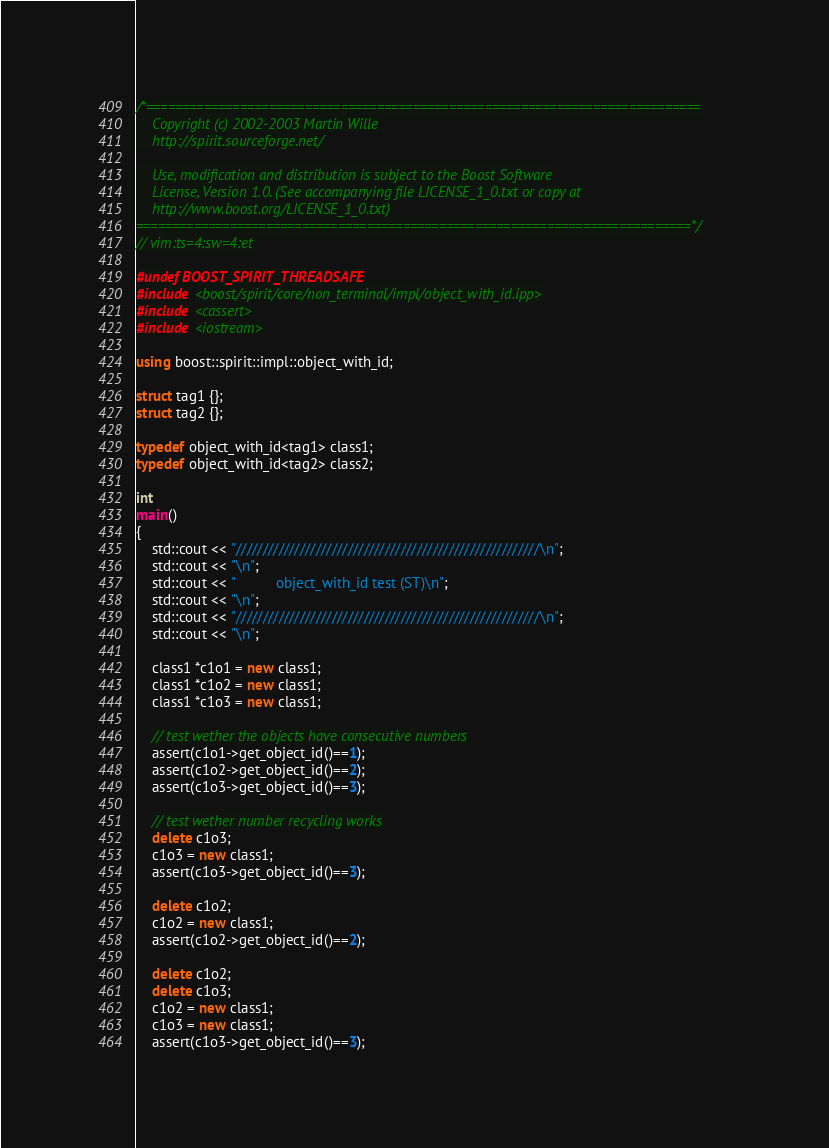<code> <loc_0><loc_0><loc_500><loc_500><_C++_>/*=============================================================================
    Copyright (c) 2002-2003 Martin Wille
    http://spirit.sourceforge.net/

    Use, modification and distribution is subject to the Boost Software
    License, Version 1.0. (See accompanying file LICENSE_1_0.txt or copy at
    http://www.boost.org/LICENSE_1_0.txt)
=============================================================================*/
// vim:ts=4:sw=4:et

#undef BOOST_SPIRIT_THREADSAFE
#include <boost/spirit/core/non_terminal/impl/object_with_id.ipp>
#include <cassert>
#include <iostream>

using boost::spirit::impl::object_with_id;

struct tag1 {};
struct tag2 {};

typedef object_with_id<tag1> class1;
typedef object_with_id<tag2> class2;

int
main()
{
    std::cout << "/////////////////////////////////////////////////////////\n";
    std::cout << "\n";
    std::cout << "          object_with_id test (ST)\n";
    std::cout << "\n";
    std::cout << "/////////////////////////////////////////////////////////\n";
    std::cout << "\n";

    class1 *c1o1 = new class1;
    class1 *c1o2 = new class1;
    class1 *c1o3 = new class1;

    // test wether the objects have consecutive numbers
    assert(c1o1->get_object_id()==1);
    assert(c1o2->get_object_id()==2);
    assert(c1o3->get_object_id()==3);

    // test wether number recycling works
    delete c1o3;
    c1o3 = new class1;
    assert(c1o3->get_object_id()==3);

    delete c1o2;
    c1o2 = new class1;
    assert(c1o2->get_object_id()==2);

    delete c1o2;
    delete c1o3;
    c1o2 = new class1;
    c1o3 = new class1;
    assert(c1o3->get_object_id()==3);</code> 